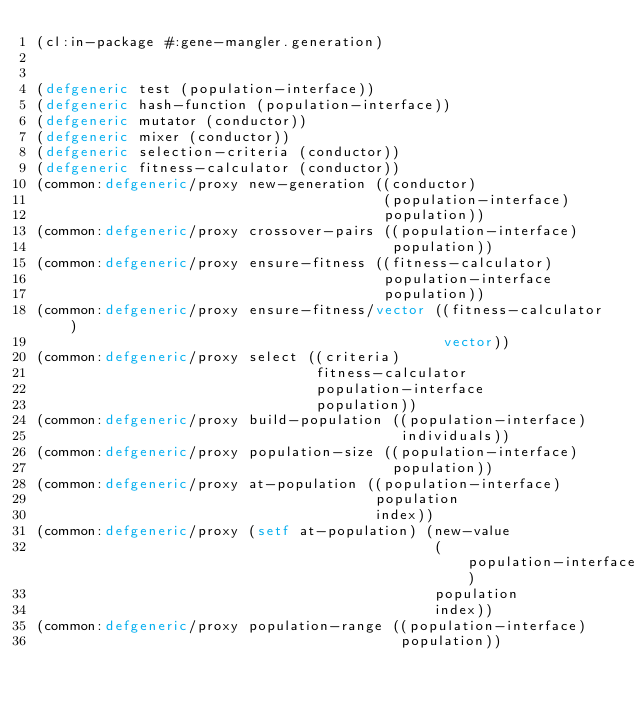Convert code to text. <code><loc_0><loc_0><loc_500><loc_500><_Lisp_>(cl:in-package #:gene-mangler.generation)


(defgeneric test (population-interface))
(defgeneric hash-function (population-interface))
(defgeneric mutator (conductor))
(defgeneric mixer (conductor))
(defgeneric selection-criteria (conductor))
(defgeneric fitness-calculator (conductor))
(common:defgeneric/proxy new-generation ((conductor)
                                         (population-interface)
                                         population))
(common:defgeneric/proxy crossover-pairs ((population-interface)
                                          population))
(common:defgeneric/proxy ensure-fitness ((fitness-calculator)
                                         population-interface
                                         population))
(common:defgeneric/proxy ensure-fitness/vector ((fitness-calculator)
                                                vector))
(common:defgeneric/proxy select ((criteria)
                                 fitness-calculator
                                 population-interface
                                 population))
(common:defgeneric/proxy build-population ((population-interface)
                                           individuals))
(common:defgeneric/proxy population-size ((population-interface)
                                          population))
(common:defgeneric/proxy at-population ((population-interface)
                                        population
                                        index))
(common:defgeneric/proxy (setf at-population) (new-value
                                               (population-interface)
                                               population
                                               index))
(common:defgeneric/proxy population-range ((population-interface)
                                           population))
</code> 